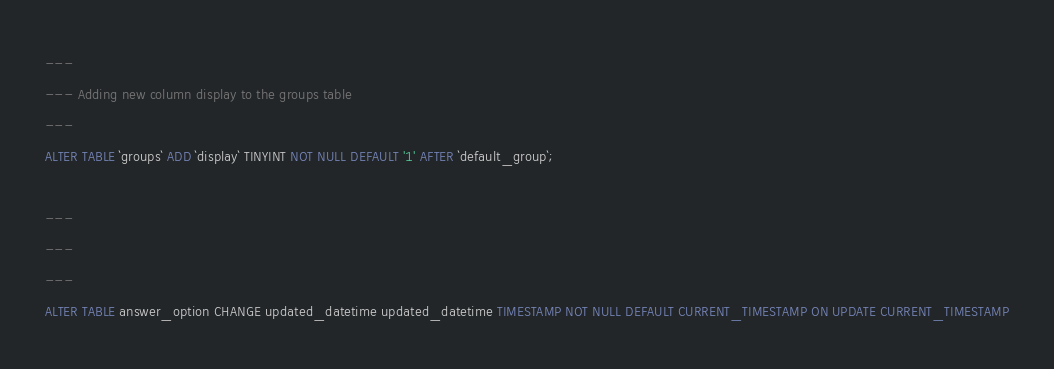Convert code to text. <code><loc_0><loc_0><loc_500><loc_500><_SQL_>---
--- Adding new column display to the groups table
---
ALTER TABLE `groups` ADD `display` TINYINT NOT NULL DEFAULT '1' AFTER `default_group`;

---
---
---
ALTER TABLE answer_option CHANGE updated_datetime updated_datetime TIMESTAMP NOT NULL DEFAULT CURRENT_TIMESTAMP ON UPDATE CURRENT_TIMESTAMP</code> 